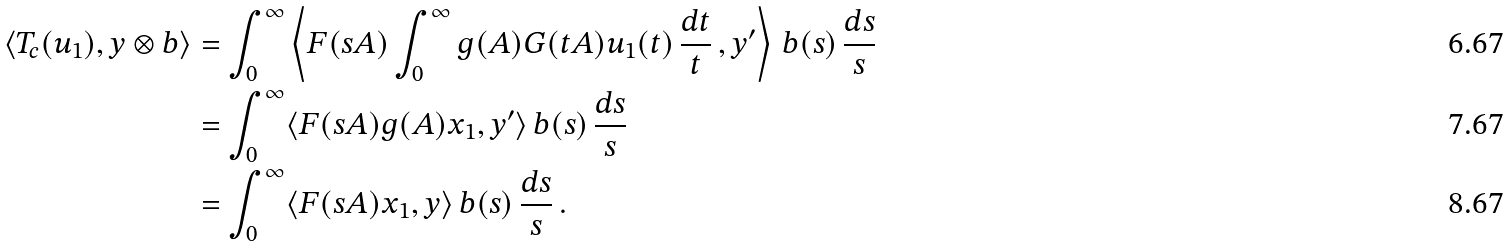Convert formula to latex. <formula><loc_0><loc_0><loc_500><loc_500>\langle T _ { c } ( u _ { 1 } ) , y \otimes b \rangle & = \int _ { 0 } ^ { \infty } \left \langle F ( s A ) \int _ { 0 } ^ { \infty } g ( A ) G ( t A ) u _ { 1 } ( t ) \, \frac { d t } { t } \, , y ^ { \prime } \right \rangle \, b ( s ) \, \frac { d s } { s } \\ & = \int _ { 0 } ^ { \infty } \langle F ( s A ) g ( A ) x _ { 1 } , y ^ { \prime } \rangle \, b ( s ) \, \frac { d s } { s } \\ & = \int _ { 0 } ^ { \infty } \langle F ( s A ) x _ { 1 } , y \rangle \, b ( s ) \, \frac { d s } { s } \, .</formula> 